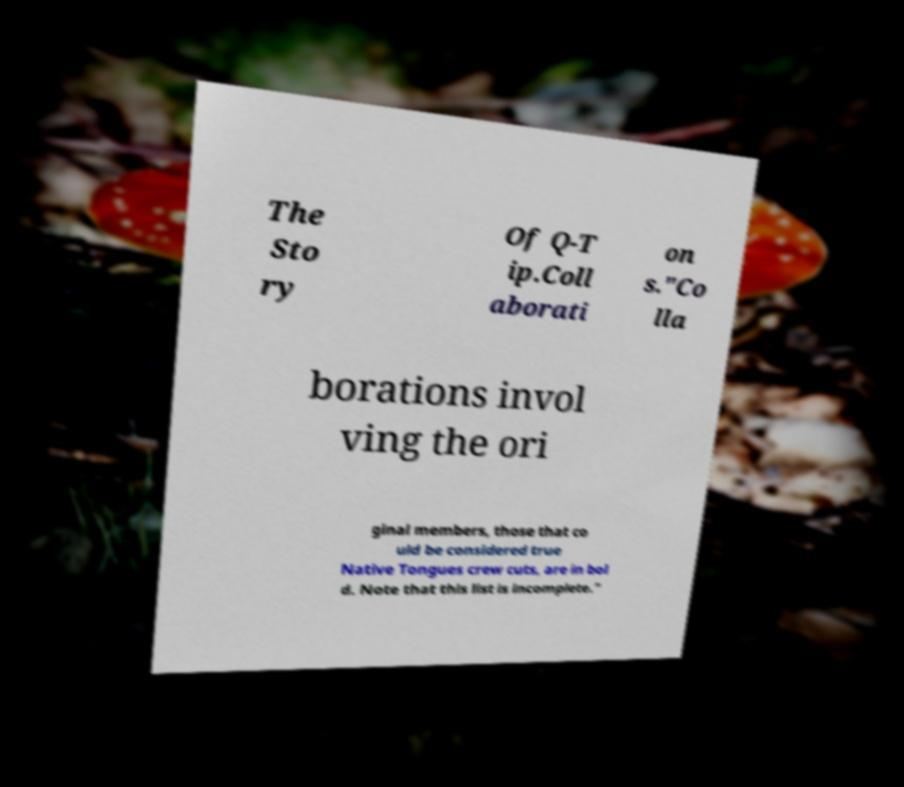Could you assist in decoding the text presented in this image and type it out clearly? The Sto ry Of Q-T ip.Coll aborati on s."Co lla borations invol ving the ori ginal members, those that co uld be considered true Native Tongues crew cuts, are in bol d. Note that this list is incomplete." 